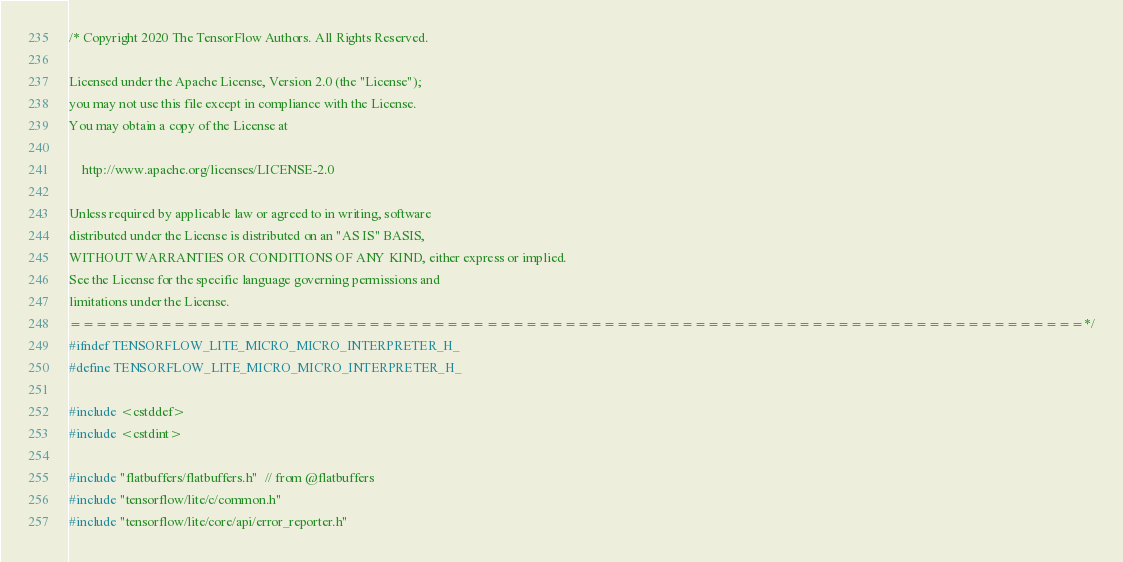Convert code to text. <code><loc_0><loc_0><loc_500><loc_500><_C_>/* Copyright 2020 The TensorFlow Authors. All Rights Reserved.

Licensed under the Apache License, Version 2.0 (the "License");
you may not use this file except in compliance with the License.
You may obtain a copy of the License at

    http://www.apache.org/licenses/LICENSE-2.0

Unless required by applicable law or agreed to in writing, software
distributed under the License is distributed on an "AS IS" BASIS,
WITHOUT WARRANTIES OR CONDITIONS OF ANY KIND, either express or implied.
See the License for the specific language governing permissions and
limitations under the License.
==============================================================================*/
#ifndef TENSORFLOW_LITE_MICRO_MICRO_INTERPRETER_H_
#define TENSORFLOW_LITE_MICRO_MICRO_INTERPRETER_H_

#include <cstddef>
#include <cstdint>

#include "flatbuffers/flatbuffers.h"  // from @flatbuffers
#include "tensorflow/lite/c/common.h"
#include "tensorflow/lite/core/api/error_reporter.h"</code> 